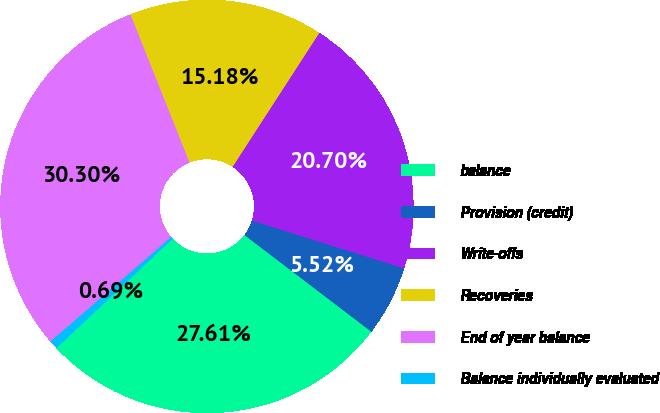<chart> <loc_0><loc_0><loc_500><loc_500><pie_chart><fcel>balance<fcel>Provision (credit)<fcel>Write-offs<fcel>Recoveries<fcel>End of year balance<fcel>Balance individually evaluated<nl><fcel>27.61%<fcel>5.52%<fcel>20.7%<fcel>15.18%<fcel>30.3%<fcel>0.69%<nl></chart> 